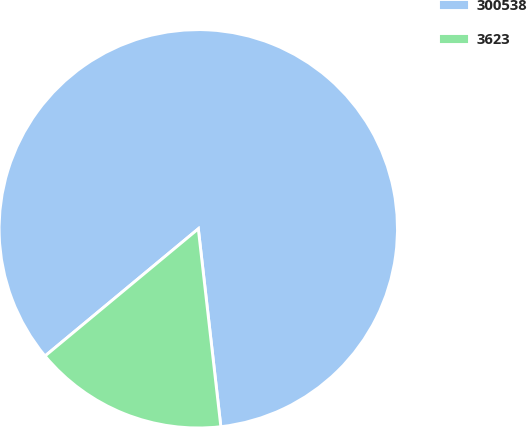<chart> <loc_0><loc_0><loc_500><loc_500><pie_chart><fcel>300538<fcel>3623<nl><fcel>84.22%<fcel>15.78%<nl></chart> 